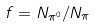<formula> <loc_0><loc_0><loc_500><loc_500>f = N _ { \pi ^ { 0 } } / N _ { \pi }</formula> 